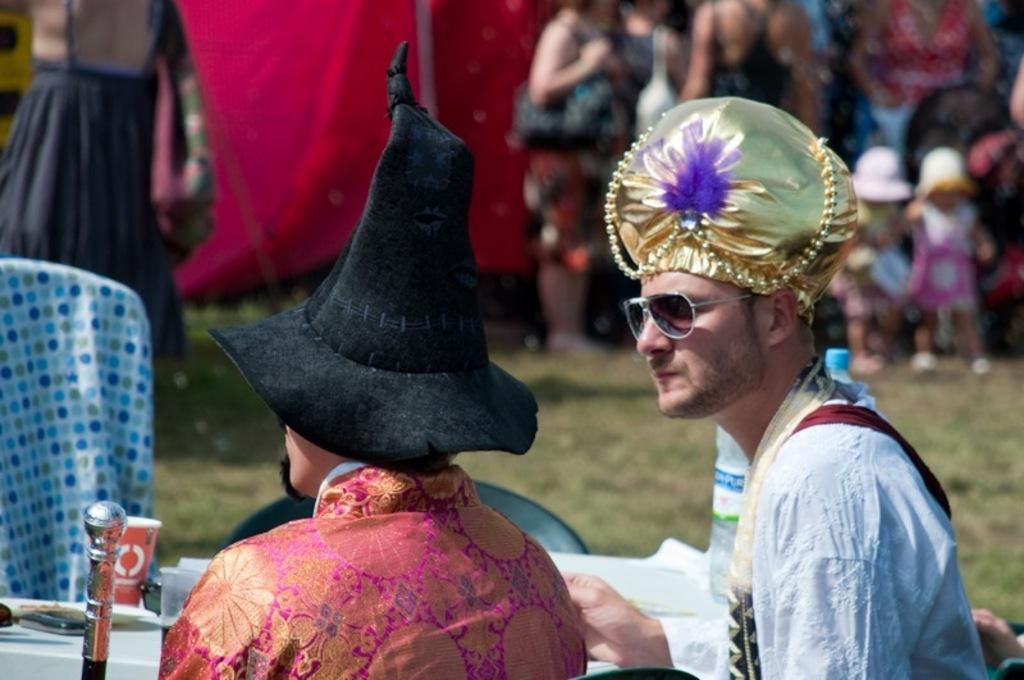What are the people at the bottom of the image doing? The people at the bottom of the image are sitting. What is located behind the sitting people? There is a table behind the sitting people. What can be found on the table? There are cups and products on the table. What are the people at the top of the image doing? The people at the top of the image are standing. What type of doctor is examining the shape of the cups in the image? There is no doctor present in the image, nor is there any mention of examining the shape of the cups. 